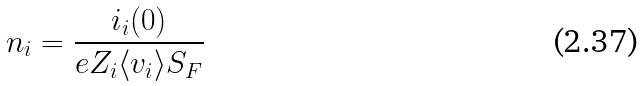<formula> <loc_0><loc_0><loc_500><loc_500>n _ { i } = \frac { i _ { i } ( 0 ) } { e Z _ { i } \langle v _ { i } \rangle S _ { F } }</formula> 